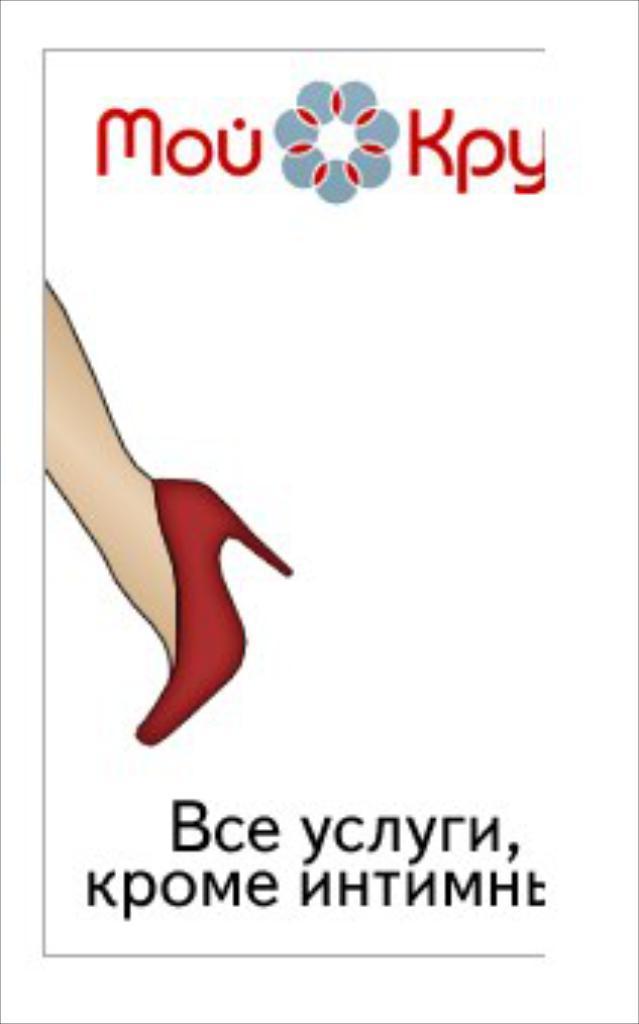How would you summarize this image in a sentence or two? This picture contains a poster. In this poster, we see the leg of the women wearing red color sandal. We see some text written on the poster. In the background, it is white in color. 